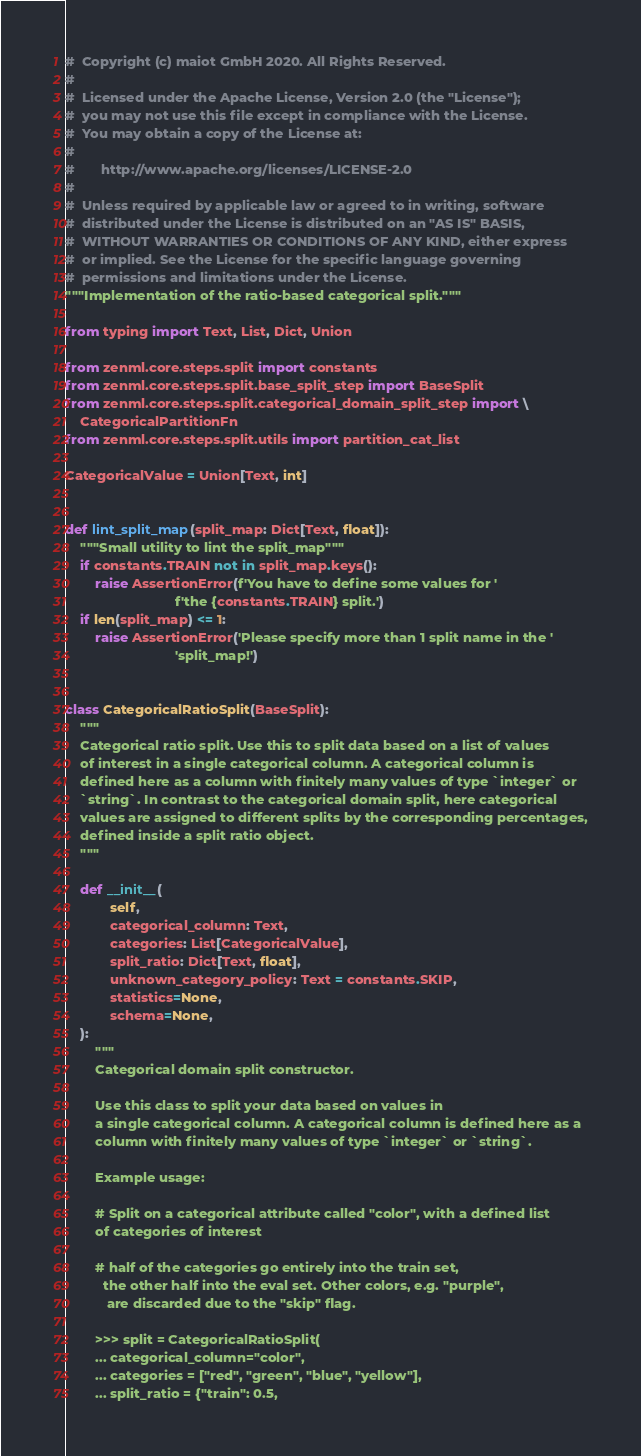Convert code to text. <code><loc_0><loc_0><loc_500><loc_500><_Python_>#  Copyright (c) maiot GmbH 2020. All Rights Reserved.
#
#  Licensed under the Apache License, Version 2.0 (the "License");
#  you may not use this file except in compliance with the License.
#  You may obtain a copy of the License at:
#
#       http://www.apache.org/licenses/LICENSE-2.0
#
#  Unless required by applicable law or agreed to in writing, software
#  distributed under the License is distributed on an "AS IS" BASIS,
#  WITHOUT WARRANTIES OR CONDITIONS OF ANY KIND, either express
#  or implied. See the License for the specific language governing
#  permissions and limitations under the License.
"""Implementation of the ratio-based categorical split."""

from typing import Text, List, Dict, Union

from zenml.core.steps.split import constants
from zenml.core.steps.split.base_split_step import BaseSplit
from zenml.core.steps.split.categorical_domain_split_step import \
    CategoricalPartitionFn
from zenml.core.steps.split.utils import partition_cat_list

CategoricalValue = Union[Text, int]


def lint_split_map(split_map: Dict[Text, float]):
    """Small utility to lint the split_map"""
    if constants.TRAIN not in split_map.keys():
        raise AssertionError(f'You have to define some values for '
                             f'the {constants.TRAIN} split.')
    if len(split_map) <= 1:
        raise AssertionError('Please specify more than 1 split name in the '
                             'split_map!')


class CategoricalRatioSplit(BaseSplit):
    """
    Categorical ratio split. Use this to split data based on a list of values
    of interest in a single categorical column. A categorical column is
    defined here as a column with finitely many values of type `integer` or
    `string`. In contrast to the categorical domain split, here categorical
    values are assigned to different splits by the corresponding percentages,
    defined inside a split ratio object.
    """

    def __init__(
            self,
            categorical_column: Text,
            categories: List[CategoricalValue],
            split_ratio: Dict[Text, float],
            unknown_category_policy: Text = constants.SKIP,
            statistics=None,
            schema=None,
    ):
        """
        Categorical domain split constructor.

        Use this class to split your data based on values in
        a single categorical column. A categorical column is defined here as a
        column with finitely many values of type `integer` or `string`.

        Example usage:

        # Split on a categorical attribute called "color", with a defined list
        of categories of interest

        # half of the categories go entirely into the train set,
          the other half into the eval set. Other colors, e.g. "purple",
           are discarded due to the "skip" flag.

        >>> split = CategoricalRatioSplit(
        ... categorical_column="color",
        ... categories = ["red", "green", "blue", "yellow"],
        ... split_ratio = {"train": 0.5,</code> 